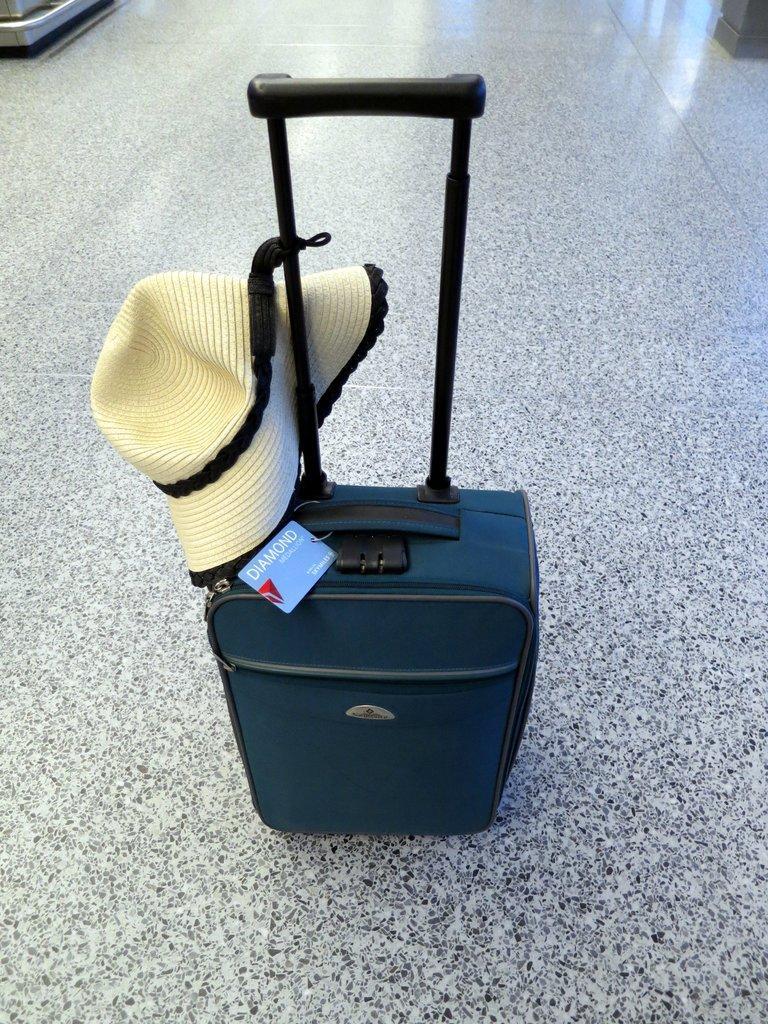Could you give a brief overview of what you see in this image? In this picture we have a bag and Cap is attached to it these are placed on a Floor. 